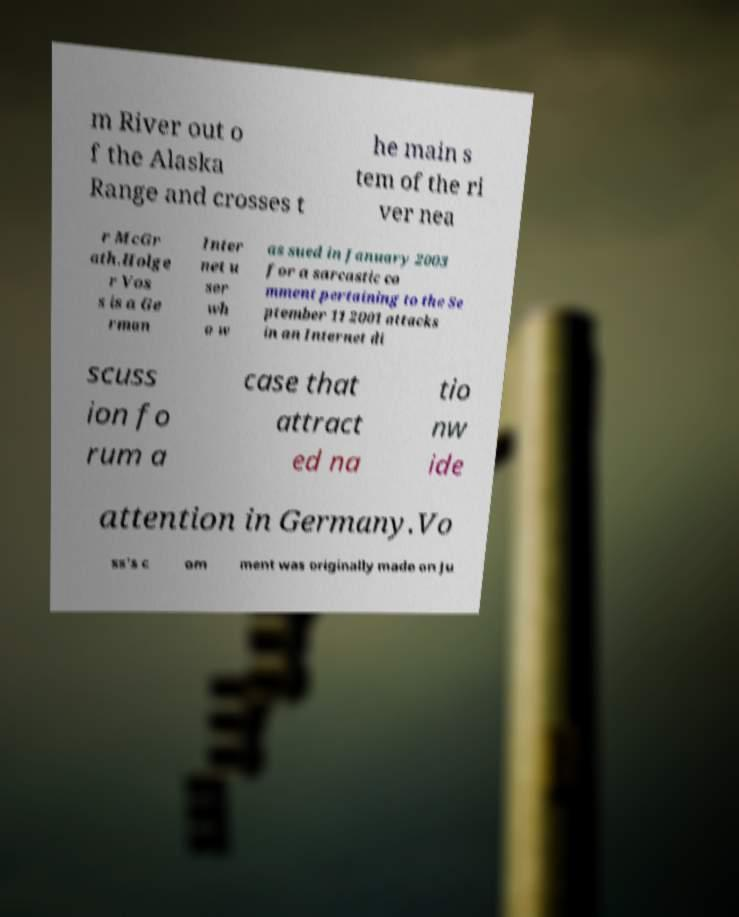What messages or text are displayed in this image? I need them in a readable, typed format. m River out o f the Alaska Range and crosses t he main s tem of the ri ver nea r McGr ath.Holge r Vos s is a Ge rman Inter net u ser wh o w as sued in January 2003 for a sarcastic co mment pertaining to the Se ptember 11 2001 attacks in an Internet di scuss ion fo rum a case that attract ed na tio nw ide attention in Germany.Vo ss's c om ment was originally made on Ju 